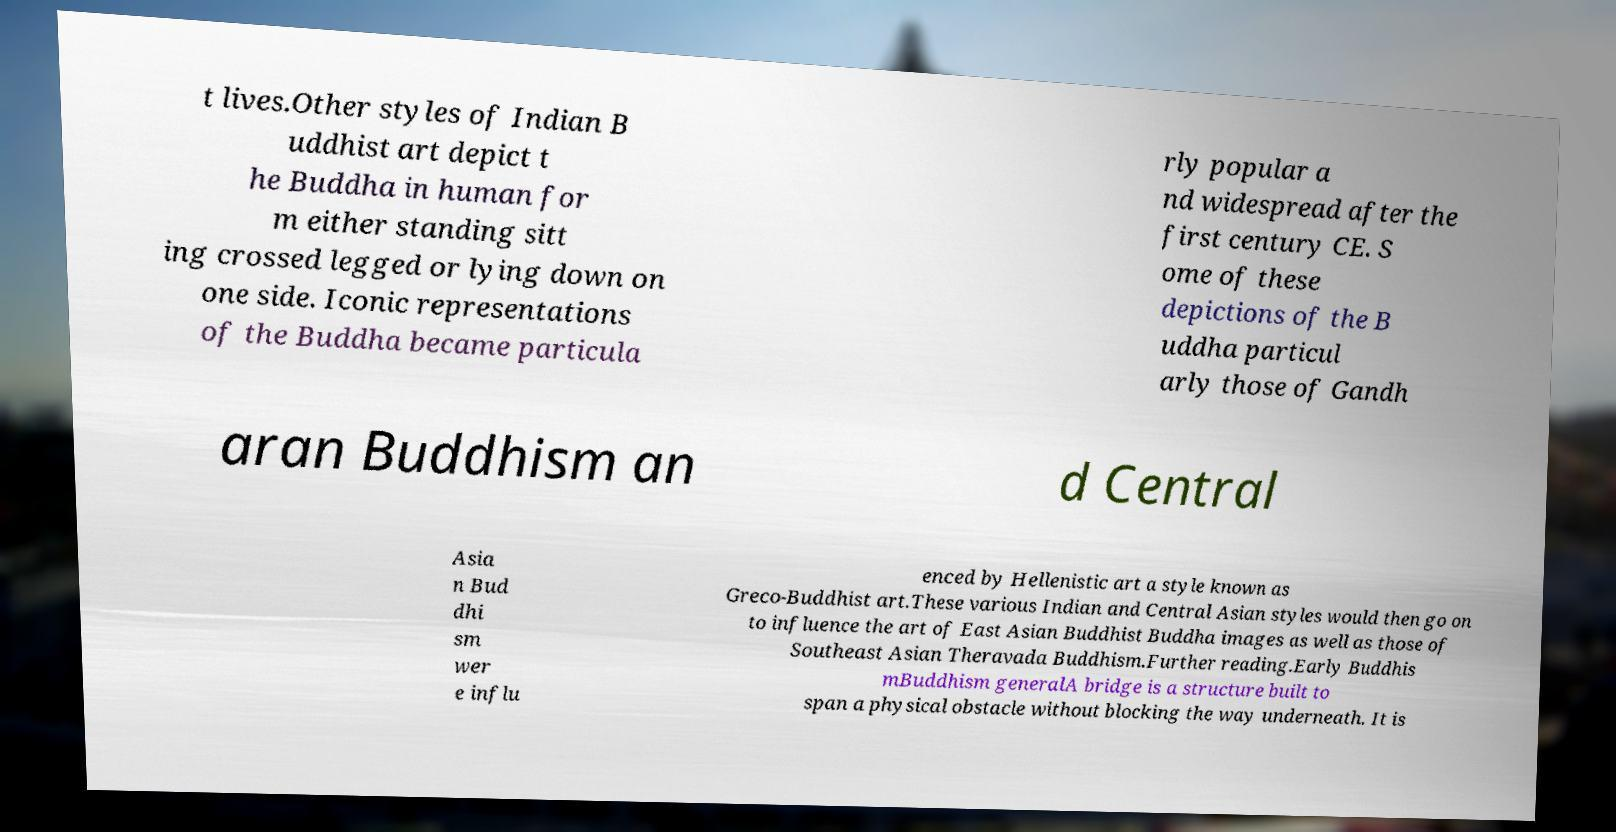For documentation purposes, I need the text within this image transcribed. Could you provide that? t lives.Other styles of Indian B uddhist art depict t he Buddha in human for m either standing sitt ing crossed legged or lying down on one side. Iconic representations of the Buddha became particula rly popular a nd widespread after the first century CE. S ome of these depictions of the B uddha particul arly those of Gandh aran Buddhism an d Central Asia n Bud dhi sm wer e influ enced by Hellenistic art a style known as Greco-Buddhist art.These various Indian and Central Asian styles would then go on to influence the art of East Asian Buddhist Buddha images as well as those of Southeast Asian Theravada Buddhism.Further reading.Early Buddhis mBuddhism generalA bridge is a structure built to span a physical obstacle without blocking the way underneath. It is 